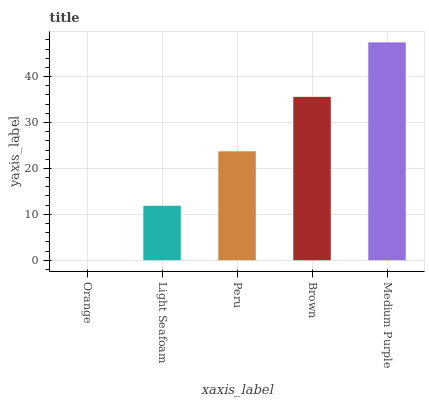Is Orange the minimum?
Answer yes or no. Yes. Is Medium Purple the maximum?
Answer yes or no. Yes. Is Light Seafoam the minimum?
Answer yes or no. No. Is Light Seafoam the maximum?
Answer yes or no. No. Is Light Seafoam greater than Orange?
Answer yes or no. Yes. Is Orange less than Light Seafoam?
Answer yes or no. Yes. Is Orange greater than Light Seafoam?
Answer yes or no. No. Is Light Seafoam less than Orange?
Answer yes or no. No. Is Peru the high median?
Answer yes or no. Yes. Is Peru the low median?
Answer yes or no. Yes. Is Brown the high median?
Answer yes or no. No. Is Brown the low median?
Answer yes or no. No. 